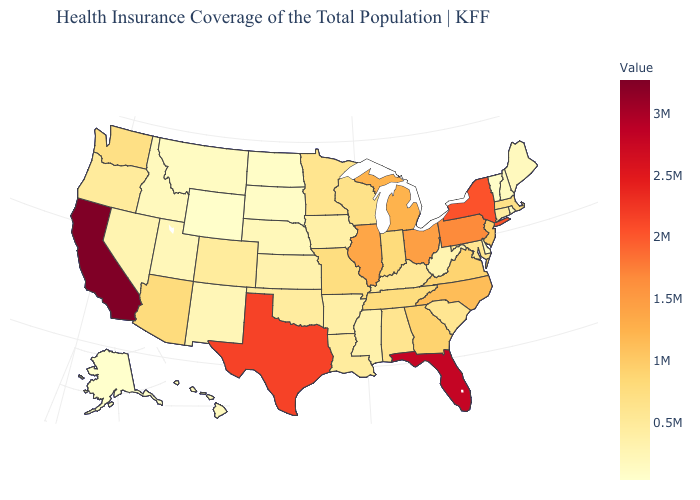Which states hav the highest value in the West?
Write a very short answer. California. Does the map have missing data?
Be succinct. No. Does Arizona have the highest value in the USA?
Answer briefly. No. Does California have the highest value in the West?
Concise answer only. Yes. Does Michigan have a higher value than California?
Answer briefly. No. Among the states that border Pennsylvania , does West Virginia have the highest value?
Short answer required. No. 